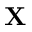<formula> <loc_0><loc_0><loc_500><loc_500>X</formula> 